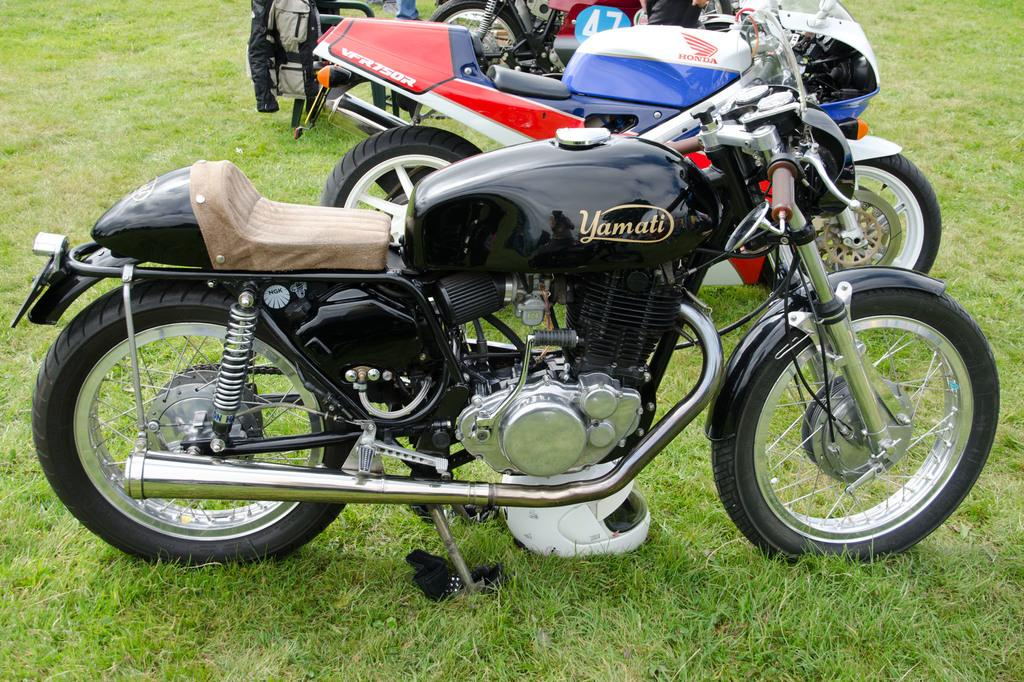How many motorbikes are in the image? There are three motorbikes in the image. Where are the motorbikes located? The motorbikes are parked on the grass. What can be seen in the background of the image? There are people, a chair, and a jacket in the background of the image. What is the purpose of the rat in the image? There is no rat present in the image, so it is not possible to determine its purpose. 